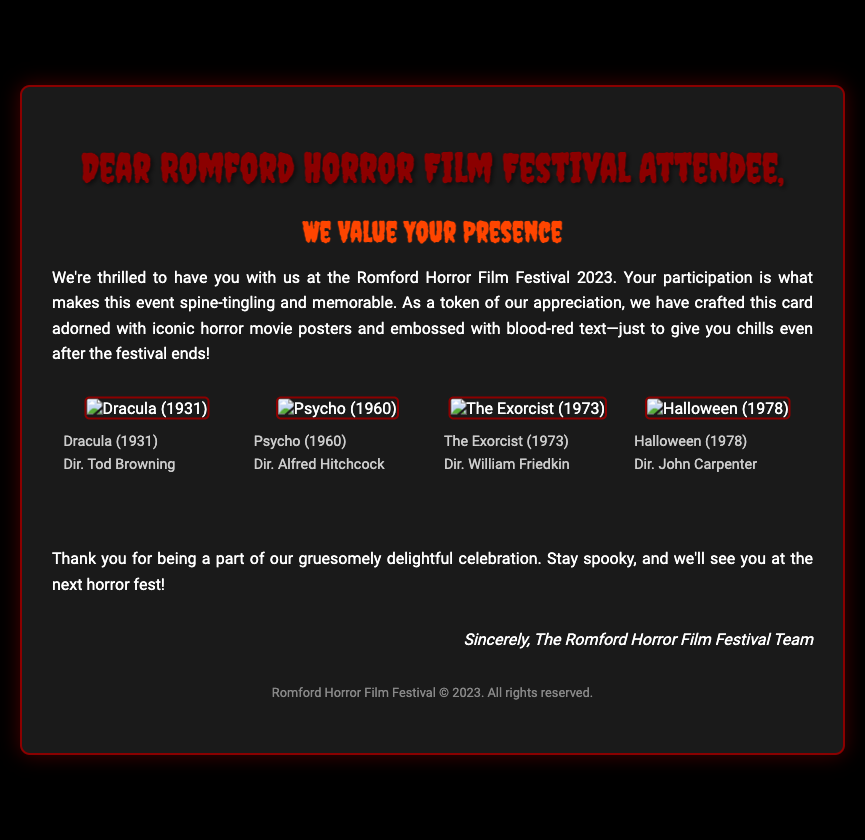What is the title of the card? The title of the card is given as the first heading in the document, which is "Dear Romford Horror Film Festival Attendee."
Answer: Dear Romford Horror Film Festival Attendee How many horror movie posters are featured on the card? The document mentions four horror movie posters displayed in a flex container.
Answer: Four What year is the Romford Horror Film Festival? The year of the festival is mentioned in the opening paragraph of the card.
Answer: 2023 Which director is associated with "Psycho"? The director of the film "Psycho" is stated under its corresponding poster on the card.
Answer: Alfred Hitchcock What color is the embossed text on the card? The description of the card highlights the color of the embossed text as "blood-red."
Answer: Blood-red Why is the card designed with horror movie themes? The purpose of using horror movie themes is because they are iconic and relate to the festival's theme, making the card fitting and memorable.
Answer: To enhance the festival's theme Who signed the appreciation card? The appreciation card is signed by the team involved with organizing the festival, as indicated in the signature section.
Answer: The Romford Horror Film Festival Team What is the background color of the card? The background color is specified in the card's styling information, which mentions a dark theme.
Answer: Black What is the overall mood conveyed by the card? The overall mood of the card is described as "spine-tingling and memorable" based on the wording found in the document.
Answer: Spine-tingling 